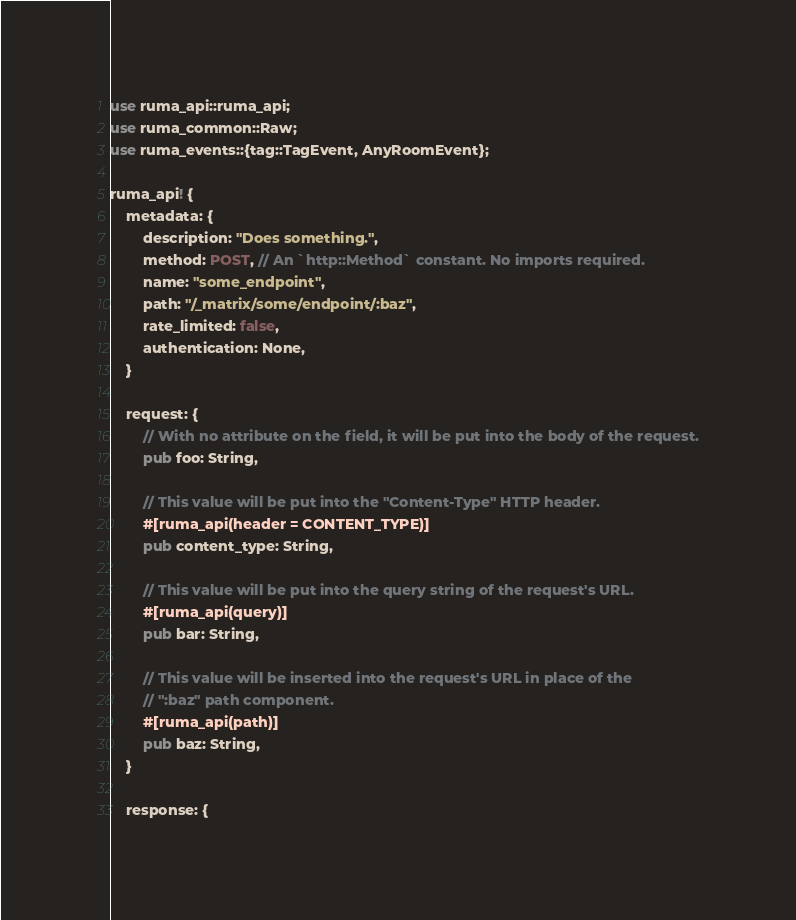<code> <loc_0><loc_0><loc_500><loc_500><_Rust_>use ruma_api::ruma_api;
use ruma_common::Raw;
use ruma_events::{tag::TagEvent, AnyRoomEvent};

ruma_api! {
    metadata: {
        description: "Does something.",
        method: POST, // An `http::Method` constant. No imports required.
        name: "some_endpoint",
        path: "/_matrix/some/endpoint/:baz",
        rate_limited: false,
        authentication: None,
    }

    request: {
        // With no attribute on the field, it will be put into the body of the request.
        pub foo: String,

        // This value will be put into the "Content-Type" HTTP header.
        #[ruma_api(header = CONTENT_TYPE)]
        pub content_type: String,

        // This value will be put into the query string of the request's URL.
        #[ruma_api(query)]
        pub bar: String,

        // This value will be inserted into the request's URL in place of the
        // ":baz" path component.
        #[ruma_api(path)]
        pub baz: String,
    }

    response: {</code> 